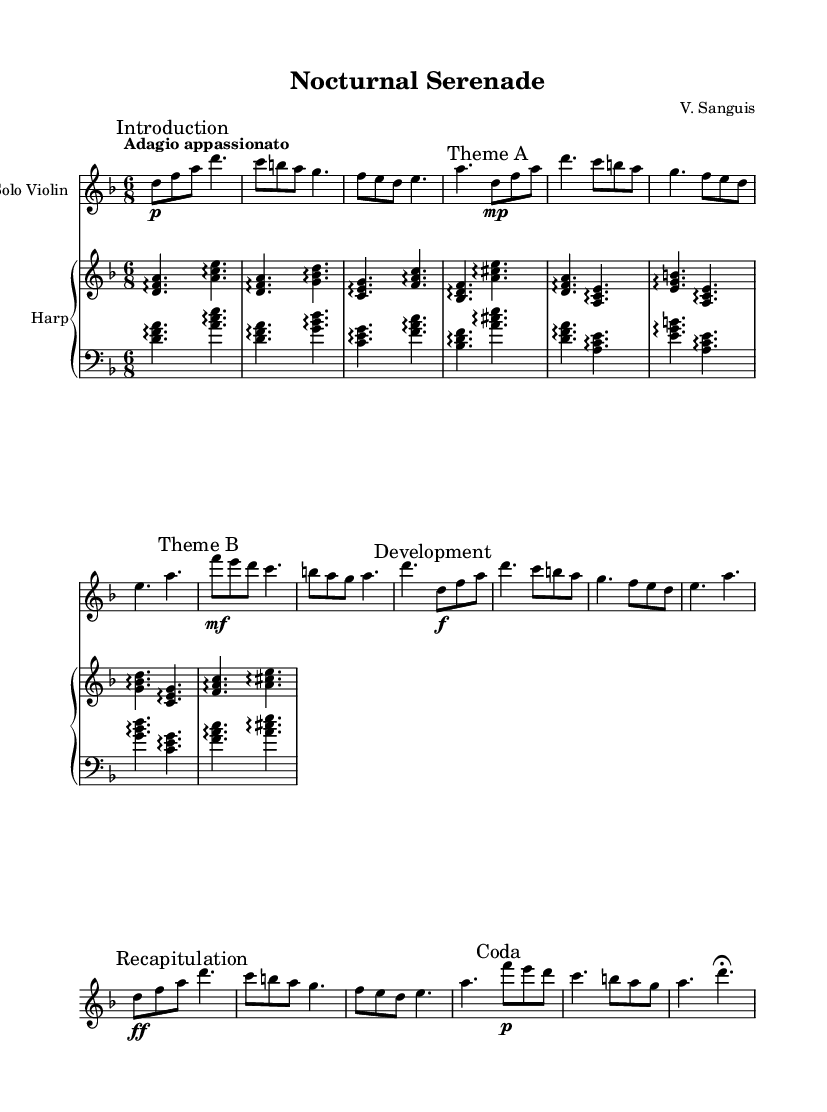What is the key signature of this music? The key signature is indicated by the presence of one flat, which signifies D minor.
Answer: D minor What is the time signature of the piece? The time signature is shown as 6 over 8, indicating a compound duple meter with six eighth notes in each measure.
Answer: 6/8 What is the tempo marking for this piece? The tempo marking is given as "Adagio appassionato," which suggests a slow and passionate performance.
Answer: Adagio appassionato What is the dynamic marking for Theme A? The dynamic marking for Theme A is marked as "mp," which indicates mezzo-piano or moderately quiet.
Answer: mp How many sections can be identified in this music? The music contains five distinct sections: Introduction, Theme A, Theme B, Development, Recapitulation, and Coda.
Answer: 5 Which instrument plays the main melody in this piece? The main melody is played by the solo violin, which is indicated as the primary voice in the score.
Answer: Solo Violin What is the significance of the tempo indication in relation to vampire seduction themes? The "Adagio appassionato" tempo signifies a slow, emotional pace, which enhances the romantic and seductive essence often found in vampire stories, creating an atmosphere of tension and allure.
Answer: Enhances seduction 